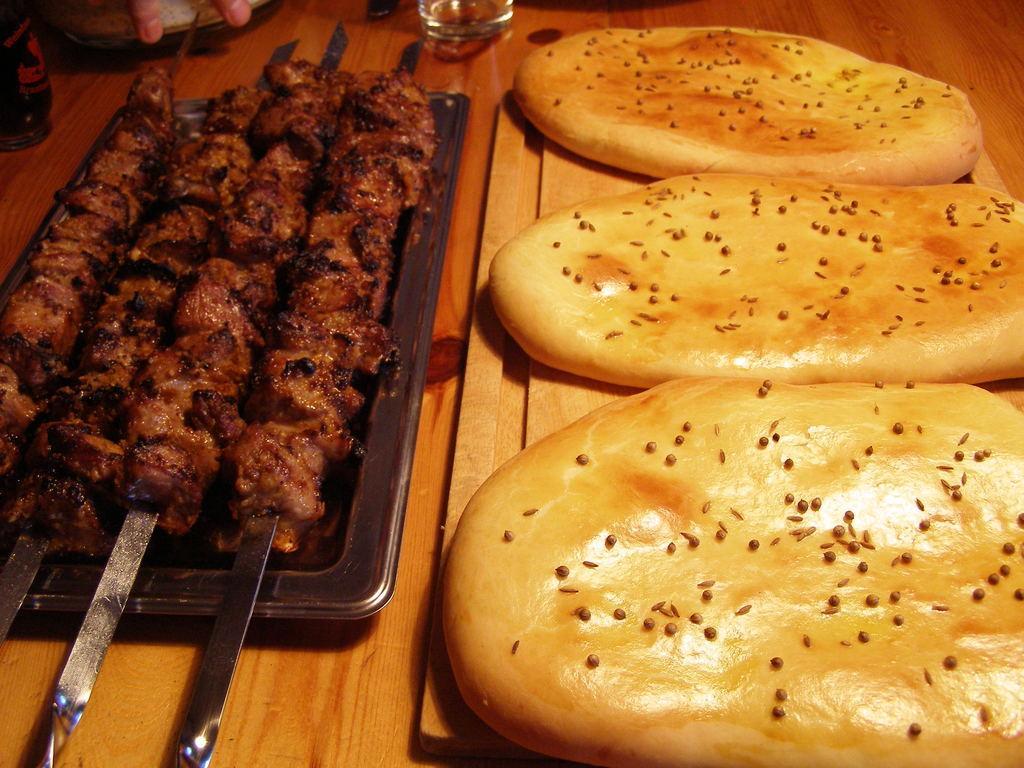Could you give a brief overview of what you see in this image? In this image, I can see the food items on the plates. I think this is a wooden table with plates, glass and few other objects on it. 